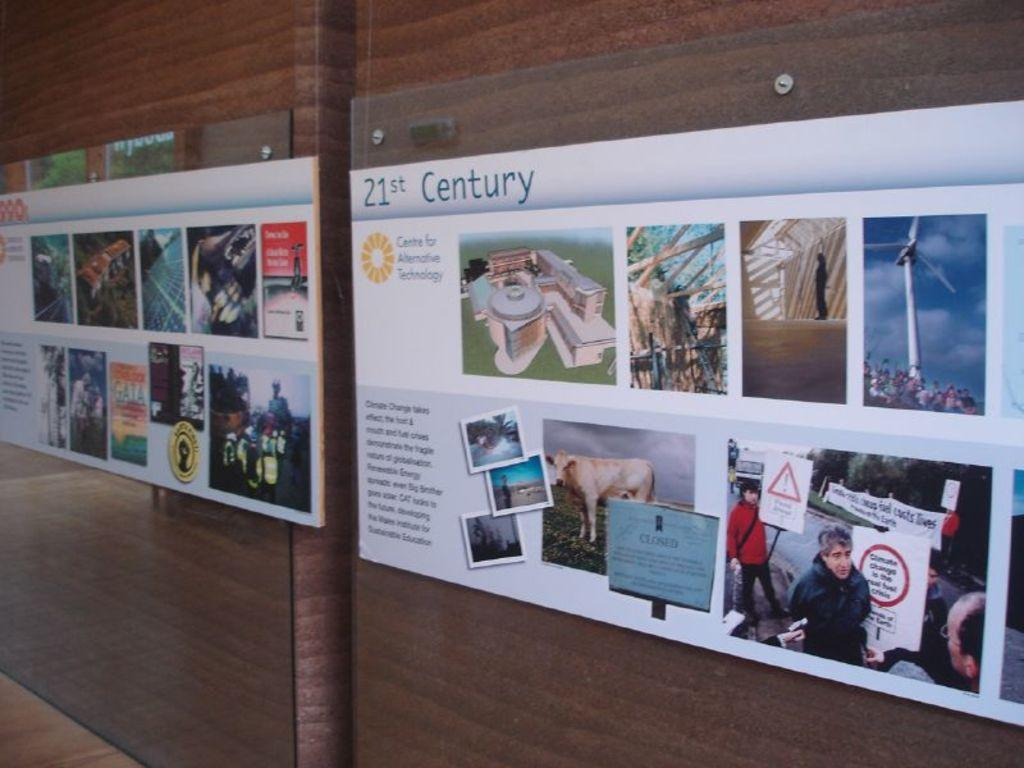Provide a one-sentence caption for the provided image. Two posters are displayed side by side on a wall that contain images and text regarding alternative technology. 